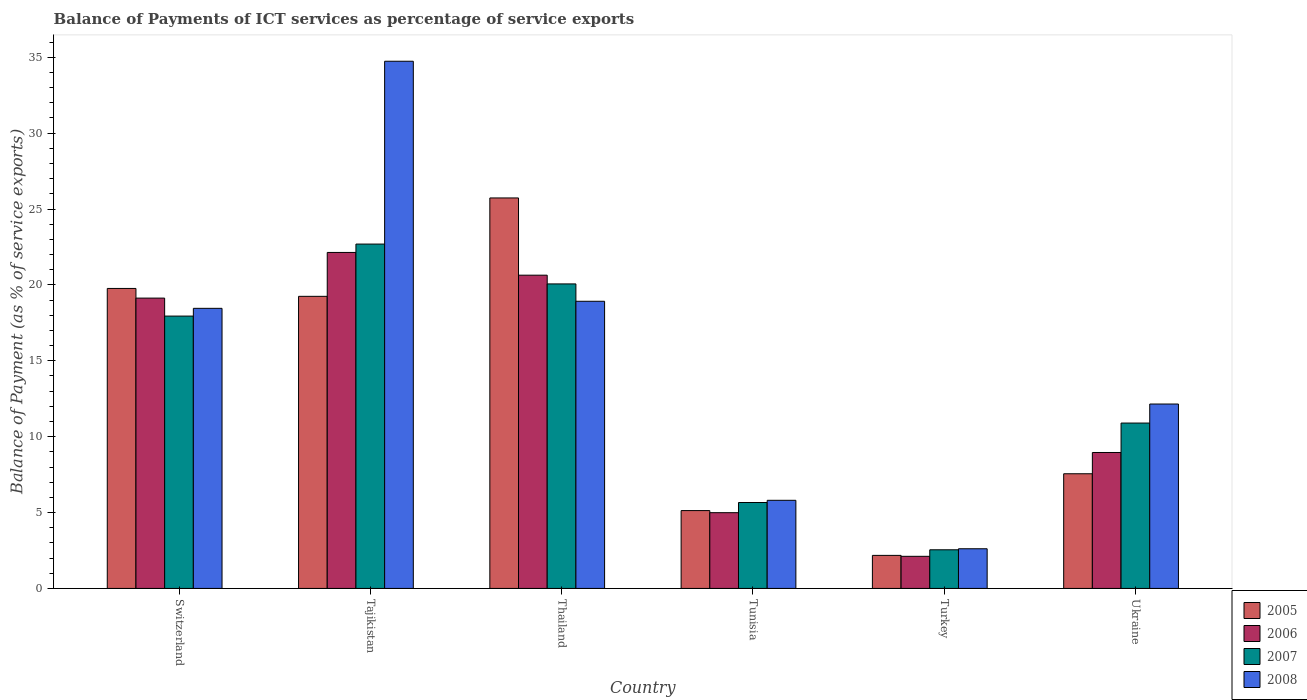How many different coloured bars are there?
Make the answer very short. 4. Are the number of bars per tick equal to the number of legend labels?
Give a very brief answer. Yes. How many bars are there on the 5th tick from the left?
Make the answer very short. 4. What is the label of the 6th group of bars from the left?
Keep it short and to the point. Ukraine. What is the balance of payments of ICT services in 2008 in Switzerland?
Provide a succinct answer. 18.46. Across all countries, what is the maximum balance of payments of ICT services in 2005?
Make the answer very short. 25.73. Across all countries, what is the minimum balance of payments of ICT services in 2008?
Keep it short and to the point. 2.61. In which country was the balance of payments of ICT services in 2006 maximum?
Your response must be concise. Tajikistan. In which country was the balance of payments of ICT services in 2007 minimum?
Offer a terse response. Turkey. What is the total balance of payments of ICT services in 2005 in the graph?
Provide a succinct answer. 79.6. What is the difference between the balance of payments of ICT services in 2008 in Tunisia and that in Ukraine?
Give a very brief answer. -6.34. What is the difference between the balance of payments of ICT services in 2006 in Turkey and the balance of payments of ICT services in 2008 in Tajikistan?
Offer a terse response. -32.62. What is the average balance of payments of ICT services in 2005 per country?
Make the answer very short. 13.27. What is the difference between the balance of payments of ICT services of/in 2005 and balance of payments of ICT services of/in 2007 in Thailand?
Your answer should be very brief. 5.66. What is the ratio of the balance of payments of ICT services in 2008 in Switzerland to that in Tajikistan?
Offer a very short reply. 0.53. Is the balance of payments of ICT services in 2007 in Switzerland less than that in Turkey?
Offer a terse response. No. Is the difference between the balance of payments of ICT services in 2005 in Tajikistan and Ukraine greater than the difference between the balance of payments of ICT services in 2007 in Tajikistan and Ukraine?
Give a very brief answer. No. What is the difference between the highest and the second highest balance of payments of ICT services in 2008?
Offer a very short reply. -16.28. What is the difference between the highest and the lowest balance of payments of ICT services in 2006?
Your answer should be very brief. 20.02. In how many countries, is the balance of payments of ICT services in 2008 greater than the average balance of payments of ICT services in 2008 taken over all countries?
Offer a very short reply. 3. Is it the case that in every country, the sum of the balance of payments of ICT services in 2008 and balance of payments of ICT services in 2007 is greater than the balance of payments of ICT services in 2006?
Keep it short and to the point. Yes. Are all the bars in the graph horizontal?
Give a very brief answer. No. How many countries are there in the graph?
Ensure brevity in your answer.  6. What is the difference between two consecutive major ticks on the Y-axis?
Your answer should be compact. 5. Does the graph contain any zero values?
Make the answer very short. No. What is the title of the graph?
Your answer should be compact. Balance of Payments of ICT services as percentage of service exports. What is the label or title of the Y-axis?
Give a very brief answer. Balance of Payment (as % of service exports). What is the Balance of Payment (as % of service exports) of 2005 in Switzerland?
Give a very brief answer. 19.77. What is the Balance of Payment (as % of service exports) in 2006 in Switzerland?
Make the answer very short. 19.13. What is the Balance of Payment (as % of service exports) of 2007 in Switzerland?
Provide a succinct answer. 17.94. What is the Balance of Payment (as % of service exports) in 2008 in Switzerland?
Your answer should be very brief. 18.46. What is the Balance of Payment (as % of service exports) in 2005 in Tajikistan?
Give a very brief answer. 19.25. What is the Balance of Payment (as % of service exports) in 2006 in Tajikistan?
Make the answer very short. 22.14. What is the Balance of Payment (as % of service exports) in 2007 in Tajikistan?
Keep it short and to the point. 22.69. What is the Balance of Payment (as % of service exports) of 2008 in Tajikistan?
Your answer should be compact. 34.74. What is the Balance of Payment (as % of service exports) of 2005 in Thailand?
Give a very brief answer. 25.73. What is the Balance of Payment (as % of service exports) in 2006 in Thailand?
Your response must be concise. 20.64. What is the Balance of Payment (as % of service exports) in 2007 in Thailand?
Offer a terse response. 20.06. What is the Balance of Payment (as % of service exports) in 2008 in Thailand?
Offer a terse response. 18.92. What is the Balance of Payment (as % of service exports) in 2005 in Tunisia?
Give a very brief answer. 5.13. What is the Balance of Payment (as % of service exports) of 2006 in Tunisia?
Offer a terse response. 4.99. What is the Balance of Payment (as % of service exports) in 2007 in Tunisia?
Offer a terse response. 5.66. What is the Balance of Payment (as % of service exports) of 2008 in Tunisia?
Your response must be concise. 5.81. What is the Balance of Payment (as % of service exports) of 2005 in Turkey?
Your answer should be very brief. 2.18. What is the Balance of Payment (as % of service exports) in 2006 in Turkey?
Offer a terse response. 2.12. What is the Balance of Payment (as % of service exports) of 2007 in Turkey?
Make the answer very short. 2.55. What is the Balance of Payment (as % of service exports) of 2008 in Turkey?
Your answer should be compact. 2.61. What is the Balance of Payment (as % of service exports) in 2005 in Ukraine?
Make the answer very short. 7.56. What is the Balance of Payment (as % of service exports) in 2006 in Ukraine?
Keep it short and to the point. 8.96. What is the Balance of Payment (as % of service exports) in 2007 in Ukraine?
Your answer should be very brief. 10.9. What is the Balance of Payment (as % of service exports) in 2008 in Ukraine?
Give a very brief answer. 12.15. Across all countries, what is the maximum Balance of Payment (as % of service exports) of 2005?
Ensure brevity in your answer.  25.73. Across all countries, what is the maximum Balance of Payment (as % of service exports) of 2006?
Your answer should be compact. 22.14. Across all countries, what is the maximum Balance of Payment (as % of service exports) of 2007?
Give a very brief answer. 22.69. Across all countries, what is the maximum Balance of Payment (as % of service exports) in 2008?
Your response must be concise. 34.74. Across all countries, what is the minimum Balance of Payment (as % of service exports) in 2005?
Your answer should be compact. 2.18. Across all countries, what is the minimum Balance of Payment (as % of service exports) in 2006?
Your answer should be very brief. 2.12. Across all countries, what is the minimum Balance of Payment (as % of service exports) of 2007?
Offer a terse response. 2.55. Across all countries, what is the minimum Balance of Payment (as % of service exports) in 2008?
Keep it short and to the point. 2.61. What is the total Balance of Payment (as % of service exports) in 2005 in the graph?
Keep it short and to the point. 79.6. What is the total Balance of Payment (as % of service exports) of 2006 in the graph?
Provide a short and direct response. 77.97. What is the total Balance of Payment (as % of service exports) of 2007 in the graph?
Your answer should be very brief. 79.8. What is the total Balance of Payment (as % of service exports) of 2008 in the graph?
Make the answer very short. 92.68. What is the difference between the Balance of Payment (as % of service exports) in 2005 in Switzerland and that in Tajikistan?
Ensure brevity in your answer.  0.52. What is the difference between the Balance of Payment (as % of service exports) of 2006 in Switzerland and that in Tajikistan?
Provide a succinct answer. -3.01. What is the difference between the Balance of Payment (as % of service exports) in 2007 in Switzerland and that in Tajikistan?
Provide a short and direct response. -4.74. What is the difference between the Balance of Payment (as % of service exports) of 2008 in Switzerland and that in Tajikistan?
Offer a terse response. -16.28. What is the difference between the Balance of Payment (as % of service exports) in 2005 in Switzerland and that in Thailand?
Offer a terse response. -5.96. What is the difference between the Balance of Payment (as % of service exports) of 2006 in Switzerland and that in Thailand?
Offer a terse response. -1.51. What is the difference between the Balance of Payment (as % of service exports) in 2007 in Switzerland and that in Thailand?
Offer a terse response. -2.12. What is the difference between the Balance of Payment (as % of service exports) in 2008 in Switzerland and that in Thailand?
Offer a terse response. -0.46. What is the difference between the Balance of Payment (as % of service exports) of 2005 in Switzerland and that in Tunisia?
Provide a succinct answer. 14.64. What is the difference between the Balance of Payment (as % of service exports) in 2006 in Switzerland and that in Tunisia?
Ensure brevity in your answer.  14.14. What is the difference between the Balance of Payment (as % of service exports) of 2007 in Switzerland and that in Tunisia?
Give a very brief answer. 12.28. What is the difference between the Balance of Payment (as % of service exports) of 2008 in Switzerland and that in Tunisia?
Provide a succinct answer. 12.65. What is the difference between the Balance of Payment (as % of service exports) of 2005 in Switzerland and that in Turkey?
Your answer should be compact. 17.59. What is the difference between the Balance of Payment (as % of service exports) of 2006 in Switzerland and that in Turkey?
Provide a succinct answer. 17.01. What is the difference between the Balance of Payment (as % of service exports) of 2007 in Switzerland and that in Turkey?
Give a very brief answer. 15.4. What is the difference between the Balance of Payment (as % of service exports) in 2008 in Switzerland and that in Turkey?
Make the answer very short. 15.84. What is the difference between the Balance of Payment (as % of service exports) of 2005 in Switzerland and that in Ukraine?
Your answer should be compact. 12.21. What is the difference between the Balance of Payment (as % of service exports) in 2006 in Switzerland and that in Ukraine?
Give a very brief answer. 10.17. What is the difference between the Balance of Payment (as % of service exports) of 2007 in Switzerland and that in Ukraine?
Offer a very short reply. 7.05. What is the difference between the Balance of Payment (as % of service exports) of 2008 in Switzerland and that in Ukraine?
Your response must be concise. 6.31. What is the difference between the Balance of Payment (as % of service exports) in 2005 in Tajikistan and that in Thailand?
Ensure brevity in your answer.  -6.48. What is the difference between the Balance of Payment (as % of service exports) in 2006 in Tajikistan and that in Thailand?
Provide a short and direct response. 1.5. What is the difference between the Balance of Payment (as % of service exports) of 2007 in Tajikistan and that in Thailand?
Give a very brief answer. 2.62. What is the difference between the Balance of Payment (as % of service exports) of 2008 in Tajikistan and that in Thailand?
Ensure brevity in your answer.  15.82. What is the difference between the Balance of Payment (as % of service exports) in 2005 in Tajikistan and that in Tunisia?
Your answer should be compact. 14.12. What is the difference between the Balance of Payment (as % of service exports) in 2006 in Tajikistan and that in Tunisia?
Your answer should be very brief. 17.15. What is the difference between the Balance of Payment (as % of service exports) of 2007 in Tajikistan and that in Tunisia?
Provide a succinct answer. 17.03. What is the difference between the Balance of Payment (as % of service exports) of 2008 in Tajikistan and that in Tunisia?
Ensure brevity in your answer.  28.93. What is the difference between the Balance of Payment (as % of service exports) of 2005 in Tajikistan and that in Turkey?
Your response must be concise. 17.07. What is the difference between the Balance of Payment (as % of service exports) in 2006 in Tajikistan and that in Turkey?
Offer a very short reply. 20.02. What is the difference between the Balance of Payment (as % of service exports) in 2007 in Tajikistan and that in Turkey?
Your answer should be compact. 20.14. What is the difference between the Balance of Payment (as % of service exports) in 2008 in Tajikistan and that in Turkey?
Make the answer very short. 32.12. What is the difference between the Balance of Payment (as % of service exports) in 2005 in Tajikistan and that in Ukraine?
Provide a succinct answer. 11.69. What is the difference between the Balance of Payment (as % of service exports) in 2006 in Tajikistan and that in Ukraine?
Offer a terse response. 13.18. What is the difference between the Balance of Payment (as % of service exports) of 2007 in Tajikistan and that in Ukraine?
Your answer should be very brief. 11.79. What is the difference between the Balance of Payment (as % of service exports) in 2008 in Tajikistan and that in Ukraine?
Offer a very short reply. 22.59. What is the difference between the Balance of Payment (as % of service exports) of 2005 in Thailand and that in Tunisia?
Provide a succinct answer. 20.6. What is the difference between the Balance of Payment (as % of service exports) of 2006 in Thailand and that in Tunisia?
Make the answer very short. 15.65. What is the difference between the Balance of Payment (as % of service exports) in 2007 in Thailand and that in Tunisia?
Make the answer very short. 14.4. What is the difference between the Balance of Payment (as % of service exports) in 2008 in Thailand and that in Tunisia?
Make the answer very short. 13.11. What is the difference between the Balance of Payment (as % of service exports) of 2005 in Thailand and that in Turkey?
Your answer should be very brief. 23.55. What is the difference between the Balance of Payment (as % of service exports) in 2006 in Thailand and that in Turkey?
Provide a succinct answer. 18.52. What is the difference between the Balance of Payment (as % of service exports) of 2007 in Thailand and that in Turkey?
Offer a terse response. 17.52. What is the difference between the Balance of Payment (as % of service exports) of 2008 in Thailand and that in Turkey?
Offer a terse response. 16.31. What is the difference between the Balance of Payment (as % of service exports) of 2005 in Thailand and that in Ukraine?
Your answer should be compact. 18.17. What is the difference between the Balance of Payment (as % of service exports) of 2006 in Thailand and that in Ukraine?
Keep it short and to the point. 11.68. What is the difference between the Balance of Payment (as % of service exports) in 2007 in Thailand and that in Ukraine?
Give a very brief answer. 9.17. What is the difference between the Balance of Payment (as % of service exports) of 2008 in Thailand and that in Ukraine?
Your answer should be compact. 6.77. What is the difference between the Balance of Payment (as % of service exports) of 2005 in Tunisia and that in Turkey?
Your answer should be compact. 2.95. What is the difference between the Balance of Payment (as % of service exports) in 2006 in Tunisia and that in Turkey?
Provide a short and direct response. 2.88. What is the difference between the Balance of Payment (as % of service exports) in 2007 in Tunisia and that in Turkey?
Your response must be concise. 3.12. What is the difference between the Balance of Payment (as % of service exports) of 2008 in Tunisia and that in Turkey?
Provide a succinct answer. 3.19. What is the difference between the Balance of Payment (as % of service exports) of 2005 in Tunisia and that in Ukraine?
Your answer should be compact. -2.43. What is the difference between the Balance of Payment (as % of service exports) of 2006 in Tunisia and that in Ukraine?
Provide a short and direct response. -3.97. What is the difference between the Balance of Payment (as % of service exports) in 2007 in Tunisia and that in Ukraine?
Give a very brief answer. -5.23. What is the difference between the Balance of Payment (as % of service exports) of 2008 in Tunisia and that in Ukraine?
Your answer should be very brief. -6.34. What is the difference between the Balance of Payment (as % of service exports) in 2005 in Turkey and that in Ukraine?
Keep it short and to the point. -5.38. What is the difference between the Balance of Payment (as % of service exports) of 2006 in Turkey and that in Ukraine?
Keep it short and to the point. -6.84. What is the difference between the Balance of Payment (as % of service exports) in 2007 in Turkey and that in Ukraine?
Your answer should be compact. -8.35. What is the difference between the Balance of Payment (as % of service exports) of 2008 in Turkey and that in Ukraine?
Make the answer very short. -9.54. What is the difference between the Balance of Payment (as % of service exports) in 2005 in Switzerland and the Balance of Payment (as % of service exports) in 2006 in Tajikistan?
Ensure brevity in your answer.  -2.37. What is the difference between the Balance of Payment (as % of service exports) of 2005 in Switzerland and the Balance of Payment (as % of service exports) of 2007 in Tajikistan?
Your answer should be compact. -2.92. What is the difference between the Balance of Payment (as % of service exports) in 2005 in Switzerland and the Balance of Payment (as % of service exports) in 2008 in Tajikistan?
Your answer should be compact. -14.97. What is the difference between the Balance of Payment (as % of service exports) of 2006 in Switzerland and the Balance of Payment (as % of service exports) of 2007 in Tajikistan?
Ensure brevity in your answer.  -3.56. What is the difference between the Balance of Payment (as % of service exports) of 2006 in Switzerland and the Balance of Payment (as % of service exports) of 2008 in Tajikistan?
Your answer should be very brief. -15.61. What is the difference between the Balance of Payment (as % of service exports) in 2007 in Switzerland and the Balance of Payment (as % of service exports) in 2008 in Tajikistan?
Your answer should be very brief. -16.79. What is the difference between the Balance of Payment (as % of service exports) in 2005 in Switzerland and the Balance of Payment (as % of service exports) in 2006 in Thailand?
Your response must be concise. -0.87. What is the difference between the Balance of Payment (as % of service exports) in 2005 in Switzerland and the Balance of Payment (as % of service exports) in 2007 in Thailand?
Ensure brevity in your answer.  -0.3. What is the difference between the Balance of Payment (as % of service exports) in 2005 in Switzerland and the Balance of Payment (as % of service exports) in 2008 in Thailand?
Offer a very short reply. 0.85. What is the difference between the Balance of Payment (as % of service exports) in 2006 in Switzerland and the Balance of Payment (as % of service exports) in 2007 in Thailand?
Offer a very short reply. -0.93. What is the difference between the Balance of Payment (as % of service exports) of 2006 in Switzerland and the Balance of Payment (as % of service exports) of 2008 in Thailand?
Your response must be concise. 0.21. What is the difference between the Balance of Payment (as % of service exports) in 2007 in Switzerland and the Balance of Payment (as % of service exports) in 2008 in Thailand?
Provide a succinct answer. -0.98. What is the difference between the Balance of Payment (as % of service exports) of 2005 in Switzerland and the Balance of Payment (as % of service exports) of 2006 in Tunisia?
Keep it short and to the point. 14.77. What is the difference between the Balance of Payment (as % of service exports) of 2005 in Switzerland and the Balance of Payment (as % of service exports) of 2007 in Tunisia?
Give a very brief answer. 14.1. What is the difference between the Balance of Payment (as % of service exports) in 2005 in Switzerland and the Balance of Payment (as % of service exports) in 2008 in Tunisia?
Ensure brevity in your answer.  13.96. What is the difference between the Balance of Payment (as % of service exports) in 2006 in Switzerland and the Balance of Payment (as % of service exports) in 2007 in Tunisia?
Offer a very short reply. 13.47. What is the difference between the Balance of Payment (as % of service exports) in 2006 in Switzerland and the Balance of Payment (as % of service exports) in 2008 in Tunisia?
Offer a very short reply. 13.32. What is the difference between the Balance of Payment (as % of service exports) in 2007 in Switzerland and the Balance of Payment (as % of service exports) in 2008 in Tunisia?
Offer a very short reply. 12.14. What is the difference between the Balance of Payment (as % of service exports) of 2005 in Switzerland and the Balance of Payment (as % of service exports) of 2006 in Turkey?
Your response must be concise. 17.65. What is the difference between the Balance of Payment (as % of service exports) of 2005 in Switzerland and the Balance of Payment (as % of service exports) of 2007 in Turkey?
Keep it short and to the point. 17.22. What is the difference between the Balance of Payment (as % of service exports) in 2005 in Switzerland and the Balance of Payment (as % of service exports) in 2008 in Turkey?
Keep it short and to the point. 17.15. What is the difference between the Balance of Payment (as % of service exports) of 2006 in Switzerland and the Balance of Payment (as % of service exports) of 2007 in Turkey?
Keep it short and to the point. 16.58. What is the difference between the Balance of Payment (as % of service exports) of 2006 in Switzerland and the Balance of Payment (as % of service exports) of 2008 in Turkey?
Your answer should be compact. 16.52. What is the difference between the Balance of Payment (as % of service exports) of 2007 in Switzerland and the Balance of Payment (as % of service exports) of 2008 in Turkey?
Offer a terse response. 15.33. What is the difference between the Balance of Payment (as % of service exports) in 2005 in Switzerland and the Balance of Payment (as % of service exports) in 2006 in Ukraine?
Your response must be concise. 10.81. What is the difference between the Balance of Payment (as % of service exports) in 2005 in Switzerland and the Balance of Payment (as % of service exports) in 2007 in Ukraine?
Provide a short and direct response. 8.87. What is the difference between the Balance of Payment (as % of service exports) in 2005 in Switzerland and the Balance of Payment (as % of service exports) in 2008 in Ukraine?
Keep it short and to the point. 7.62. What is the difference between the Balance of Payment (as % of service exports) of 2006 in Switzerland and the Balance of Payment (as % of service exports) of 2007 in Ukraine?
Your response must be concise. 8.23. What is the difference between the Balance of Payment (as % of service exports) of 2006 in Switzerland and the Balance of Payment (as % of service exports) of 2008 in Ukraine?
Give a very brief answer. 6.98. What is the difference between the Balance of Payment (as % of service exports) in 2007 in Switzerland and the Balance of Payment (as % of service exports) in 2008 in Ukraine?
Provide a short and direct response. 5.79. What is the difference between the Balance of Payment (as % of service exports) in 2005 in Tajikistan and the Balance of Payment (as % of service exports) in 2006 in Thailand?
Ensure brevity in your answer.  -1.39. What is the difference between the Balance of Payment (as % of service exports) in 2005 in Tajikistan and the Balance of Payment (as % of service exports) in 2007 in Thailand?
Your answer should be very brief. -0.82. What is the difference between the Balance of Payment (as % of service exports) of 2005 in Tajikistan and the Balance of Payment (as % of service exports) of 2008 in Thailand?
Keep it short and to the point. 0.33. What is the difference between the Balance of Payment (as % of service exports) in 2006 in Tajikistan and the Balance of Payment (as % of service exports) in 2007 in Thailand?
Offer a very short reply. 2.07. What is the difference between the Balance of Payment (as % of service exports) of 2006 in Tajikistan and the Balance of Payment (as % of service exports) of 2008 in Thailand?
Provide a succinct answer. 3.22. What is the difference between the Balance of Payment (as % of service exports) of 2007 in Tajikistan and the Balance of Payment (as % of service exports) of 2008 in Thailand?
Keep it short and to the point. 3.77. What is the difference between the Balance of Payment (as % of service exports) in 2005 in Tajikistan and the Balance of Payment (as % of service exports) in 2006 in Tunisia?
Keep it short and to the point. 14.25. What is the difference between the Balance of Payment (as % of service exports) in 2005 in Tajikistan and the Balance of Payment (as % of service exports) in 2007 in Tunisia?
Your answer should be compact. 13.58. What is the difference between the Balance of Payment (as % of service exports) of 2005 in Tajikistan and the Balance of Payment (as % of service exports) of 2008 in Tunisia?
Your response must be concise. 13.44. What is the difference between the Balance of Payment (as % of service exports) in 2006 in Tajikistan and the Balance of Payment (as % of service exports) in 2007 in Tunisia?
Your answer should be very brief. 16.48. What is the difference between the Balance of Payment (as % of service exports) in 2006 in Tajikistan and the Balance of Payment (as % of service exports) in 2008 in Tunisia?
Keep it short and to the point. 16.33. What is the difference between the Balance of Payment (as % of service exports) of 2007 in Tajikistan and the Balance of Payment (as % of service exports) of 2008 in Tunisia?
Give a very brief answer. 16.88. What is the difference between the Balance of Payment (as % of service exports) of 2005 in Tajikistan and the Balance of Payment (as % of service exports) of 2006 in Turkey?
Your response must be concise. 17.13. What is the difference between the Balance of Payment (as % of service exports) of 2005 in Tajikistan and the Balance of Payment (as % of service exports) of 2007 in Turkey?
Make the answer very short. 16.7. What is the difference between the Balance of Payment (as % of service exports) of 2005 in Tajikistan and the Balance of Payment (as % of service exports) of 2008 in Turkey?
Keep it short and to the point. 16.63. What is the difference between the Balance of Payment (as % of service exports) in 2006 in Tajikistan and the Balance of Payment (as % of service exports) in 2007 in Turkey?
Provide a short and direct response. 19.59. What is the difference between the Balance of Payment (as % of service exports) of 2006 in Tajikistan and the Balance of Payment (as % of service exports) of 2008 in Turkey?
Ensure brevity in your answer.  19.52. What is the difference between the Balance of Payment (as % of service exports) of 2007 in Tajikistan and the Balance of Payment (as % of service exports) of 2008 in Turkey?
Ensure brevity in your answer.  20.07. What is the difference between the Balance of Payment (as % of service exports) in 2005 in Tajikistan and the Balance of Payment (as % of service exports) in 2006 in Ukraine?
Your answer should be compact. 10.29. What is the difference between the Balance of Payment (as % of service exports) of 2005 in Tajikistan and the Balance of Payment (as % of service exports) of 2007 in Ukraine?
Provide a short and direct response. 8.35. What is the difference between the Balance of Payment (as % of service exports) of 2005 in Tajikistan and the Balance of Payment (as % of service exports) of 2008 in Ukraine?
Your answer should be compact. 7.1. What is the difference between the Balance of Payment (as % of service exports) in 2006 in Tajikistan and the Balance of Payment (as % of service exports) in 2007 in Ukraine?
Provide a succinct answer. 11.24. What is the difference between the Balance of Payment (as % of service exports) of 2006 in Tajikistan and the Balance of Payment (as % of service exports) of 2008 in Ukraine?
Provide a short and direct response. 9.99. What is the difference between the Balance of Payment (as % of service exports) of 2007 in Tajikistan and the Balance of Payment (as % of service exports) of 2008 in Ukraine?
Your answer should be compact. 10.54. What is the difference between the Balance of Payment (as % of service exports) in 2005 in Thailand and the Balance of Payment (as % of service exports) in 2006 in Tunisia?
Your answer should be very brief. 20.74. What is the difference between the Balance of Payment (as % of service exports) of 2005 in Thailand and the Balance of Payment (as % of service exports) of 2007 in Tunisia?
Your response must be concise. 20.07. What is the difference between the Balance of Payment (as % of service exports) of 2005 in Thailand and the Balance of Payment (as % of service exports) of 2008 in Tunisia?
Offer a terse response. 19.92. What is the difference between the Balance of Payment (as % of service exports) in 2006 in Thailand and the Balance of Payment (as % of service exports) in 2007 in Tunisia?
Provide a succinct answer. 14.98. What is the difference between the Balance of Payment (as % of service exports) in 2006 in Thailand and the Balance of Payment (as % of service exports) in 2008 in Tunisia?
Make the answer very short. 14.83. What is the difference between the Balance of Payment (as % of service exports) of 2007 in Thailand and the Balance of Payment (as % of service exports) of 2008 in Tunisia?
Give a very brief answer. 14.26. What is the difference between the Balance of Payment (as % of service exports) of 2005 in Thailand and the Balance of Payment (as % of service exports) of 2006 in Turkey?
Give a very brief answer. 23.61. What is the difference between the Balance of Payment (as % of service exports) of 2005 in Thailand and the Balance of Payment (as % of service exports) of 2007 in Turkey?
Make the answer very short. 23.18. What is the difference between the Balance of Payment (as % of service exports) of 2005 in Thailand and the Balance of Payment (as % of service exports) of 2008 in Turkey?
Make the answer very short. 23.11. What is the difference between the Balance of Payment (as % of service exports) of 2006 in Thailand and the Balance of Payment (as % of service exports) of 2007 in Turkey?
Your answer should be very brief. 18.09. What is the difference between the Balance of Payment (as % of service exports) of 2006 in Thailand and the Balance of Payment (as % of service exports) of 2008 in Turkey?
Give a very brief answer. 18.03. What is the difference between the Balance of Payment (as % of service exports) in 2007 in Thailand and the Balance of Payment (as % of service exports) in 2008 in Turkey?
Your answer should be compact. 17.45. What is the difference between the Balance of Payment (as % of service exports) in 2005 in Thailand and the Balance of Payment (as % of service exports) in 2006 in Ukraine?
Make the answer very short. 16.77. What is the difference between the Balance of Payment (as % of service exports) in 2005 in Thailand and the Balance of Payment (as % of service exports) in 2007 in Ukraine?
Make the answer very short. 14.83. What is the difference between the Balance of Payment (as % of service exports) in 2005 in Thailand and the Balance of Payment (as % of service exports) in 2008 in Ukraine?
Your answer should be very brief. 13.58. What is the difference between the Balance of Payment (as % of service exports) in 2006 in Thailand and the Balance of Payment (as % of service exports) in 2007 in Ukraine?
Provide a short and direct response. 9.74. What is the difference between the Balance of Payment (as % of service exports) in 2006 in Thailand and the Balance of Payment (as % of service exports) in 2008 in Ukraine?
Provide a short and direct response. 8.49. What is the difference between the Balance of Payment (as % of service exports) in 2007 in Thailand and the Balance of Payment (as % of service exports) in 2008 in Ukraine?
Give a very brief answer. 7.91. What is the difference between the Balance of Payment (as % of service exports) in 2005 in Tunisia and the Balance of Payment (as % of service exports) in 2006 in Turkey?
Make the answer very short. 3.01. What is the difference between the Balance of Payment (as % of service exports) of 2005 in Tunisia and the Balance of Payment (as % of service exports) of 2007 in Turkey?
Offer a very short reply. 2.58. What is the difference between the Balance of Payment (as % of service exports) in 2005 in Tunisia and the Balance of Payment (as % of service exports) in 2008 in Turkey?
Offer a very short reply. 2.52. What is the difference between the Balance of Payment (as % of service exports) of 2006 in Tunisia and the Balance of Payment (as % of service exports) of 2007 in Turkey?
Give a very brief answer. 2.44. What is the difference between the Balance of Payment (as % of service exports) of 2006 in Tunisia and the Balance of Payment (as % of service exports) of 2008 in Turkey?
Give a very brief answer. 2.38. What is the difference between the Balance of Payment (as % of service exports) in 2007 in Tunisia and the Balance of Payment (as % of service exports) in 2008 in Turkey?
Your answer should be very brief. 3.05. What is the difference between the Balance of Payment (as % of service exports) in 2005 in Tunisia and the Balance of Payment (as % of service exports) in 2006 in Ukraine?
Give a very brief answer. -3.83. What is the difference between the Balance of Payment (as % of service exports) of 2005 in Tunisia and the Balance of Payment (as % of service exports) of 2007 in Ukraine?
Your answer should be compact. -5.77. What is the difference between the Balance of Payment (as % of service exports) in 2005 in Tunisia and the Balance of Payment (as % of service exports) in 2008 in Ukraine?
Your answer should be compact. -7.02. What is the difference between the Balance of Payment (as % of service exports) in 2006 in Tunisia and the Balance of Payment (as % of service exports) in 2007 in Ukraine?
Offer a very short reply. -5.91. What is the difference between the Balance of Payment (as % of service exports) of 2006 in Tunisia and the Balance of Payment (as % of service exports) of 2008 in Ukraine?
Provide a short and direct response. -7.16. What is the difference between the Balance of Payment (as % of service exports) in 2007 in Tunisia and the Balance of Payment (as % of service exports) in 2008 in Ukraine?
Make the answer very short. -6.49. What is the difference between the Balance of Payment (as % of service exports) in 2005 in Turkey and the Balance of Payment (as % of service exports) in 2006 in Ukraine?
Your answer should be compact. -6.78. What is the difference between the Balance of Payment (as % of service exports) in 2005 in Turkey and the Balance of Payment (as % of service exports) in 2007 in Ukraine?
Offer a very short reply. -8.72. What is the difference between the Balance of Payment (as % of service exports) in 2005 in Turkey and the Balance of Payment (as % of service exports) in 2008 in Ukraine?
Provide a short and direct response. -9.97. What is the difference between the Balance of Payment (as % of service exports) of 2006 in Turkey and the Balance of Payment (as % of service exports) of 2007 in Ukraine?
Offer a very short reply. -8.78. What is the difference between the Balance of Payment (as % of service exports) in 2006 in Turkey and the Balance of Payment (as % of service exports) in 2008 in Ukraine?
Provide a succinct answer. -10.03. What is the difference between the Balance of Payment (as % of service exports) of 2007 in Turkey and the Balance of Payment (as % of service exports) of 2008 in Ukraine?
Your response must be concise. -9.6. What is the average Balance of Payment (as % of service exports) of 2005 per country?
Your response must be concise. 13.27. What is the average Balance of Payment (as % of service exports) of 2006 per country?
Your answer should be very brief. 13. What is the average Balance of Payment (as % of service exports) in 2007 per country?
Offer a very short reply. 13.3. What is the average Balance of Payment (as % of service exports) in 2008 per country?
Offer a terse response. 15.45. What is the difference between the Balance of Payment (as % of service exports) in 2005 and Balance of Payment (as % of service exports) in 2006 in Switzerland?
Ensure brevity in your answer.  0.64. What is the difference between the Balance of Payment (as % of service exports) in 2005 and Balance of Payment (as % of service exports) in 2007 in Switzerland?
Provide a succinct answer. 1.82. What is the difference between the Balance of Payment (as % of service exports) of 2005 and Balance of Payment (as % of service exports) of 2008 in Switzerland?
Your answer should be compact. 1.31. What is the difference between the Balance of Payment (as % of service exports) of 2006 and Balance of Payment (as % of service exports) of 2007 in Switzerland?
Provide a short and direct response. 1.19. What is the difference between the Balance of Payment (as % of service exports) of 2006 and Balance of Payment (as % of service exports) of 2008 in Switzerland?
Offer a terse response. 0.67. What is the difference between the Balance of Payment (as % of service exports) of 2007 and Balance of Payment (as % of service exports) of 2008 in Switzerland?
Offer a very short reply. -0.51. What is the difference between the Balance of Payment (as % of service exports) in 2005 and Balance of Payment (as % of service exports) in 2006 in Tajikistan?
Your response must be concise. -2.89. What is the difference between the Balance of Payment (as % of service exports) of 2005 and Balance of Payment (as % of service exports) of 2007 in Tajikistan?
Offer a very short reply. -3.44. What is the difference between the Balance of Payment (as % of service exports) of 2005 and Balance of Payment (as % of service exports) of 2008 in Tajikistan?
Provide a short and direct response. -15.49. What is the difference between the Balance of Payment (as % of service exports) of 2006 and Balance of Payment (as % of service exports) of 2007 in Tajikistan?
Keep it short and to the point. -0.55. What is the difference between the Balance of Payment (as % of service exports) in 2006 and Balance of Payment (as % of service exports) in 2008 in Tajikistan?
Provide a short and direct response. -12.6. What is the difference between the Balance of Payment (as % of service exports) of 2007 and Balance of Payment (as % of service exports) of 2008 in Tajikistan?
Make the answer very short. -12.05. What is the difference between the Balance of Payment (as % of service exports) of 2005 and Balance of Payment (as % of service exports) of 2006 in Thailand?
Provide a short and direct response. 5.09. What is the difference between the Balance of Payment (as % of service exports) in 2005 and Balance of Payment (as % of service exports) in 2007 in Thailand?
Provide a short and direct response. 5.66. What is the difference between the Balance of Payment (as % of service exports) of 2005 and Balance of Payment (as % of service exports) of 2008 in Thailand?
Your response must be concise. 6.81. What is the difference between the Balance of Payment (as % of service exports) in 2006 and Balance of Payment (as % of service exports) in 2007 in Thailand?
Your answer should be compact. 0.58. What is the difference between the Balance of Payment (as % of service exports) in 2006 and Balance of Payment (as % of service exports) in 2008 in Thailand?
Make the answer very short. 1.72. What is the difference between the Balance of Payment (as % of service exports) in 2007 and Balance of Payment (as % of service exports) in 2008 in Thailand?
Your answer should be very brief. 1.14. What is the difference between the Balance of Payment (as % of service exports) in 2005 and Balance of Payment (as % of service exports) in 2006 in Tunisia?
Your answer should be very brief. 0.14. What is the difference between the Balance of Payment (as % of service exports) in 2005 and Balance of Payment (as % of service exports) in 2007 in Tunisia?
Offer a terse response. -0.53. What is the difference between the Balance of Payment (as % of service exports) of 2005 and Balance of Payment (as % of service exports) of 2008 in Tunisia?
Offer a terse response. -0.68. What is the difference between the Balance of Payment (as % of service exports) in 2006 and Balance of Payment (as % of service exports) in 2007 in Tunisia?
Ensure brevity in your answer.  -0.67. What is the difference between the Balance of Payment (as % of service exports) of 2006 and Balance of Payment (as % of service exports) of 2008 in Tunisia?
Make the answer very short. -0.82. What is the difference between the Balance of Payment (as % of service exports) of 2007 and Balance of Payment (as % of service exports) of 2008 in Tunisia?
Your answer should be compact. -0.14. What is the difference between the Balance of Payment (as % of service exports) in 2005 and Balance of Payment (as % of service exports) in 2006 in Turkey?
Your response must be concise. 0.06. What is the difference between the Balance of Payment (as % of service exports) in 2005 and Balance of Payment (as % of service exports) in 2007 in Turkey?
Your answer should be very brief. -0.37. What is the difference between the Balance of Payment (as % of service exports) in 2005 and Balance of Payment (as % of service exports) in 2008 in Turkey?
Your response must be concise. -0.44. What is the difference between the Balance of Payment (as % of service exports) of 2006 and Balance of Payment (as % of service exports) of 2007 in Turkey?
Your answer should be compact. -0.43. What is the difference between the Balance of Payment (as % of service exports) in 2006 and Balance of Payment (as % of service exports) in 2008 in Turkey?
Give a very brief answer. -0.5. What is the difference between the Balance of Payment (as % of service exports) in 2007 and Balance of Payment (as % of service exports) in 2008 in Turkey?
Offer a terse response. -0.07. What is the difference between the Balance of Payment (as % of service exports) in 2005 and Balance of Payment (as % of service exports) in 2006 in Ukraine?
Provide a succinct answer. -1.4. What is the difference between the Balance of Payment (as % of service exports) of 2005 and Balance of Payment (as % of service exports) of 2007 in Ukraine?
Give a very brief answer. -3.34. What is the difference between the Balance of Payment (as % of service exports) of 2005 and Balance of Payment (as % of service exports) of 2008 in Ukraine?
Make the answer very short. -4.59. What is the difference between the Balance of Payment (as % of service exports) of 2006 and Balance of Payment (as % of service exports) of 2007 in Ukraine?
Offer a terse response. -1.94. What is the difference between the Balance of Payment (as % of service exports) in 2006 and Balance of Payment (as % of service exports) in 2008 in Ukraine?
Your answer should be very brief. -3.19. What is the difference between the Balance of Payment (as % of service exports) in 2007 and Balance of Payment (as % of service exports) in 2008 in Ukraine?
Provide a succinct answer. -1.25. What is the ratio of the Balance of Payment (as % of service exports) in 2005 in Switzerland to that in Tajikistan?
Provide a succinct answer. 1.03. What is the ratio of the Balance of Payment (as % of service exports) in 2006 in Switzerland to that in Tajikistan?
Offer a very short reply. 0.86. What is the ratio of the Balance of Payment (as % of service exports) of 2007 in Switzerland to that in Tajikistan?
Make the answer very short. 0.79. What is the ratio of the Balance of Payment (as % of service exports) in 2008 in Switzerland to that in Tajikistan?
Keep it short and to the point. 0.53. What is the ratio of the Balance of Payment (as % of service exports) in 2005 in Switzerland to that in Thailand?
Ensure brevity in your answer.  0.77. What is the ratio of the Balance of Payment (as % of service exports) in 2006 in Switzerland to that in Thailand?
Offer a very short reply. 0.93. What is the ratio of the Balance of Payment (as % of service exports) in 2007 in Switzerland to that in Thailand?
Offer a very short reply. 0.89. What is the ratio of the Balance of Payment (as % of service exports) of 2008 in Switzerland to that in Thailand?
Your response must be concise. 0.98. What is the ratio of the Balance of Payment (as % of service exports) of 2005 in Switzerland to that in Tunisia?
Offer a very short reply. 3.85. What is the ratio of the Balance of Payment (as % of service exports) in 2006 in Switzerland to that in Tunisia?
Give a very brief answer. 3.83. What is the ratio of the Balance of Payment (as % of service exports) of 2007 in Switzerland to that in Tunisia?
Ensure brevity in your answer.  3.17. What is the ratio of the Balance of Payment (as % of service exports) of 2008 in Switzerland to that in Tunisia?
Give a very brief answer. 3.18. What is the ratio of the Balance of Payment (as % of service exports) of 2005 in Switzerland to that in Turkey?
Your answer should be compact. 9.07. What is the ratio of the Balance of Payment (as % of service exports) of 2006 in Switzerland to that in Turkey?
Offer a very short reply. 9.04. What is the ratio of the Balance of Payment (as % of service exports) of 2007 in Switzerland to that in Turkey?
Your answer should be very brief. 7.05. What is the ratio of the Balance of Payment (as % of service exports) of 2008 in Switzerland to that in Turkey?
Offer a very short reply. 7.06. What is the ratio of the Balance of Payment (as % of service exports) in 2005 in Switzerland to that in Ukraine?
Make the answer very short. 2.62. What is the ratio of the Balance of Payment (as % of service exports) in 2006 in Switzerland to that in Ukraine?
Your answer should be compact. 2.14. What is the ratio of the Balance of Payment (as % of service exports) of 2007 in Switzerland to that in Ukraine?
Provide a succinct answer. 1.65. What is the ratio of the Balance of Payment (as % of service exports) in 2008 in Switzerland to that in Ukraine?
Give a very brief answer. 1.52. What is the ratio of the Balance of Payment (as % of service exports) of 2005 in Tajikistan to that in Thailand?
Your response must be concise. 0.75. What is the ratio of the Balance of Payment (as % of service exports) in 2006 in Tajikistan to that in Thailand?
Your response must be concise. 1.07. What is the ratio of the Balance of Payment (as % of service exports) of 2007 in Tajikistan to that in Thailand?
Your response must be concise. 1.13. What is the ratio of the Balance of Payment (as % of service exports) of 2008 in Tajikistan to that in Thailand?
Keep it short and to the point. 1.84. What is the ratio of the Balance of Payment (as % of service exports) of 2005 in Tajikistan to that in Tunisia?
Offer a very short reply. 3.75. What is the ratio of the Balance of Payment (as % of service exports) in 2006 in Tajikistan to that in Tunisia?
Make the answer very short. 4.44. What is the ratio of the Balance of Payment (as % of service exports) of 2007 in Tajikistan to that in Tunisia?
Provide a short and direct response. 4.01. What is the ratio of the Balance of Payment (as % of service exports) in 2008 in Tajikistan to that in Tunisia?
Your response must be concise. 5.98. What is the ratio of the Balance of Payment (as % of service exports) of 2005 in Tajikistan to that in Turkey?
Make the answer very short. 8.84. What is the ratio of the Balance of Payment (as % of service exports) in 2006 in Tajikistan to that in Turkey?
Keep it short and to the point. 10.46. What is the ratio of the Balance of Payment (as % of service exports) in 2007 in Tajikistan to that in Turkey?
Offer a terse response. 8.91. What is the ratio of the Balance of Payment (as % of service exports) of 2008 in Tajikistan to that in Turkey?
Your answer should be very brief. 13.29. What is the ratio of the Balance of Payment (as % of service exports) in 2005 in Tajikistan to that in Ukraine?
Your answer should be compact. 2.55. What is the ratio of the Balance of Payment (as % of service exports) in 2006 in Tajikistan to that in Ukraine?
Your answer should be compact. 2.47. What is the ratio of the Balance of Payment (as % of service exports) of 2007 in Tajikistan to that in Ukraine?
Offer a terse response. 2.08. What is the ratio of the Balance of Payment (as % of service exports) of 2008 in Tajikistan to that in Ukraine?
Your answer should be very brief. 2.86. What is the ratio of the Balance of Payment (as % of service exports) of 2005 in Thailand to that in Tunisia?
Provide a short and direct response. 5.02. What is the ratio of the Balance of Payment (as % of service exports) in 2006 in Thailand to that in Tunisia?
Offer a terse response. 4.14. What is the ratio of the Balance of Payment (as % of service exports) in 2007 in Thailand to that in Tunisia?
Your answer should be very brief. 3.54. What is the ratio of the Balance of Payment (as % of service exports) of 2008 in Thailand to that in Tunisia?
Offer a very short reply. 3.26. What is the ratio of the Balance of Payment (as % of service exports) of 2005 in Thailand to that in Turkey?
Your response must be concise. 11.81. What is the ratio of the Balance of Payment (as % of service exports) in 2006 in Thailand to that in Turkey?
Keep it short and to the point. 9.75. What is the ratio of the Balance of Payment (as % of service exports) in 2007 in Thailand to that in Turkey?
Ensure brevity in your answer.  7.88. What is the ratio of the Balance of Payment (as % of service exports) in 2008 in Thailand to that in Turkey?
Provide a succinct answer. 7.24. What is the ratio of the Balance of Payment (as % of service exports) of 2005 in Thailand to that in Ukraine?
Provide a short and direct response. 3.4. What is the ratio of the Balance of Payment (as % of service exports) of 2006 in Thailand to that in Ukraine?
Make the answer very short. 2.3. What is the ratio of the Balance of Payment (as % of service exports) in 2007 in Thailand to that in Ukraine?
Your response must be concise. 1.84. What is the ratio of the Balance of Payment (as % of service exports) of 2008 in Thailand to that in Ukraine?
Give a very brief answer. 1.56. What is the ratio of the Balance of Payment (as % of service exports) of 2005 in Tunisia to that in Turkey?
Offer a terse response. 2.35. What is the ratio of the Balance of Payment (as % of service exports) of 2006 in Tunisia to that in Turkey?
Ensure brevity in your answer.  2.36. What is the ratio of the Balance of Payment (as % of service exports) of 2007 in Tunisia to that in Turkey?
Ensure brevity in your answer.  2.22. What is the ratio of the Balance of Payment (as % of service exports) in 2008 in Tunisia to that in Turkey?
Your answer should be very brief. 2.22. What is the ratio of the Balance of Payment (as % of service exports) in 2005 in Tunisia to that in Ukraine?
Keep it short and to the point. 0.68. What is the ratio of the Balance of Payment (as % of service exports) of 2006 in Tunisia to that in Ukraine?
Make the answer very short. 0.56. What is the ratio of the Balance of Payment (as % of service exports) in 2007 in Tunisia to that in Ukraine?
Give a very brief answer. 0.52. What is the ratio of the Balance of Payment (as % of service exports) in 2008 in Tunisia to that in Ukraine?
Provide a succinct answer. 0.48. What is the ratio of the Balance of Payment (as % of service exports) of 2005 in Turkey to that in Ukraine?
Offer a terse response. 0.29. What is the ratio of the Balance of Payment (as % of service exports) of 2006 in Turkey to that in Ukraine?
Offer a very short reply. 0.24. What is the ratio of the Balance of Payment (as % of service exports) in 2007 in Turkey to that in Ukraine?
Give a very brief answer. 0.23. What is the ratio of the Balance of Payment (as % of service exports) in 2008 in Turkey to that in Ukraine?
Give a very brief answer. 0.22. What is the difference between the highest and the second highest Balance of Payment (as % of service exports) of 2005?
Make the answer very short. 5.96. What is the difference between the highest and the second highest Balance of Payment (as % of service exports) of 2006?
Keep it short and to the point. 1.5. What is the difference between the highest and the second highest Balance of Payment (as % of service exports) of 2007?
Give a very brief answer. 2.62. What is the difference between the highest and the second highest Balance of Payment (as % of service exports) in 2008?
Provide a short and direct response. 15.82. What is the difference between the highest and the lowest Balance of Payment (as % of service exports) in 2005?
Keep it short and to the point. 23.55. What is the difference between the highest and the lowest Balance of Payment (as % of service exports) of 2006?
Give a very brief answer. 20.02. What is the difference between the highest and the lowest Balance of Payment (as % of service exports) in 2007?
Offer a terse response. 20.14. What is the difference between the highest and the lowest Balance of Payment (as % of service exports) of 2008?
Your answer should be very brief. 32.12. 